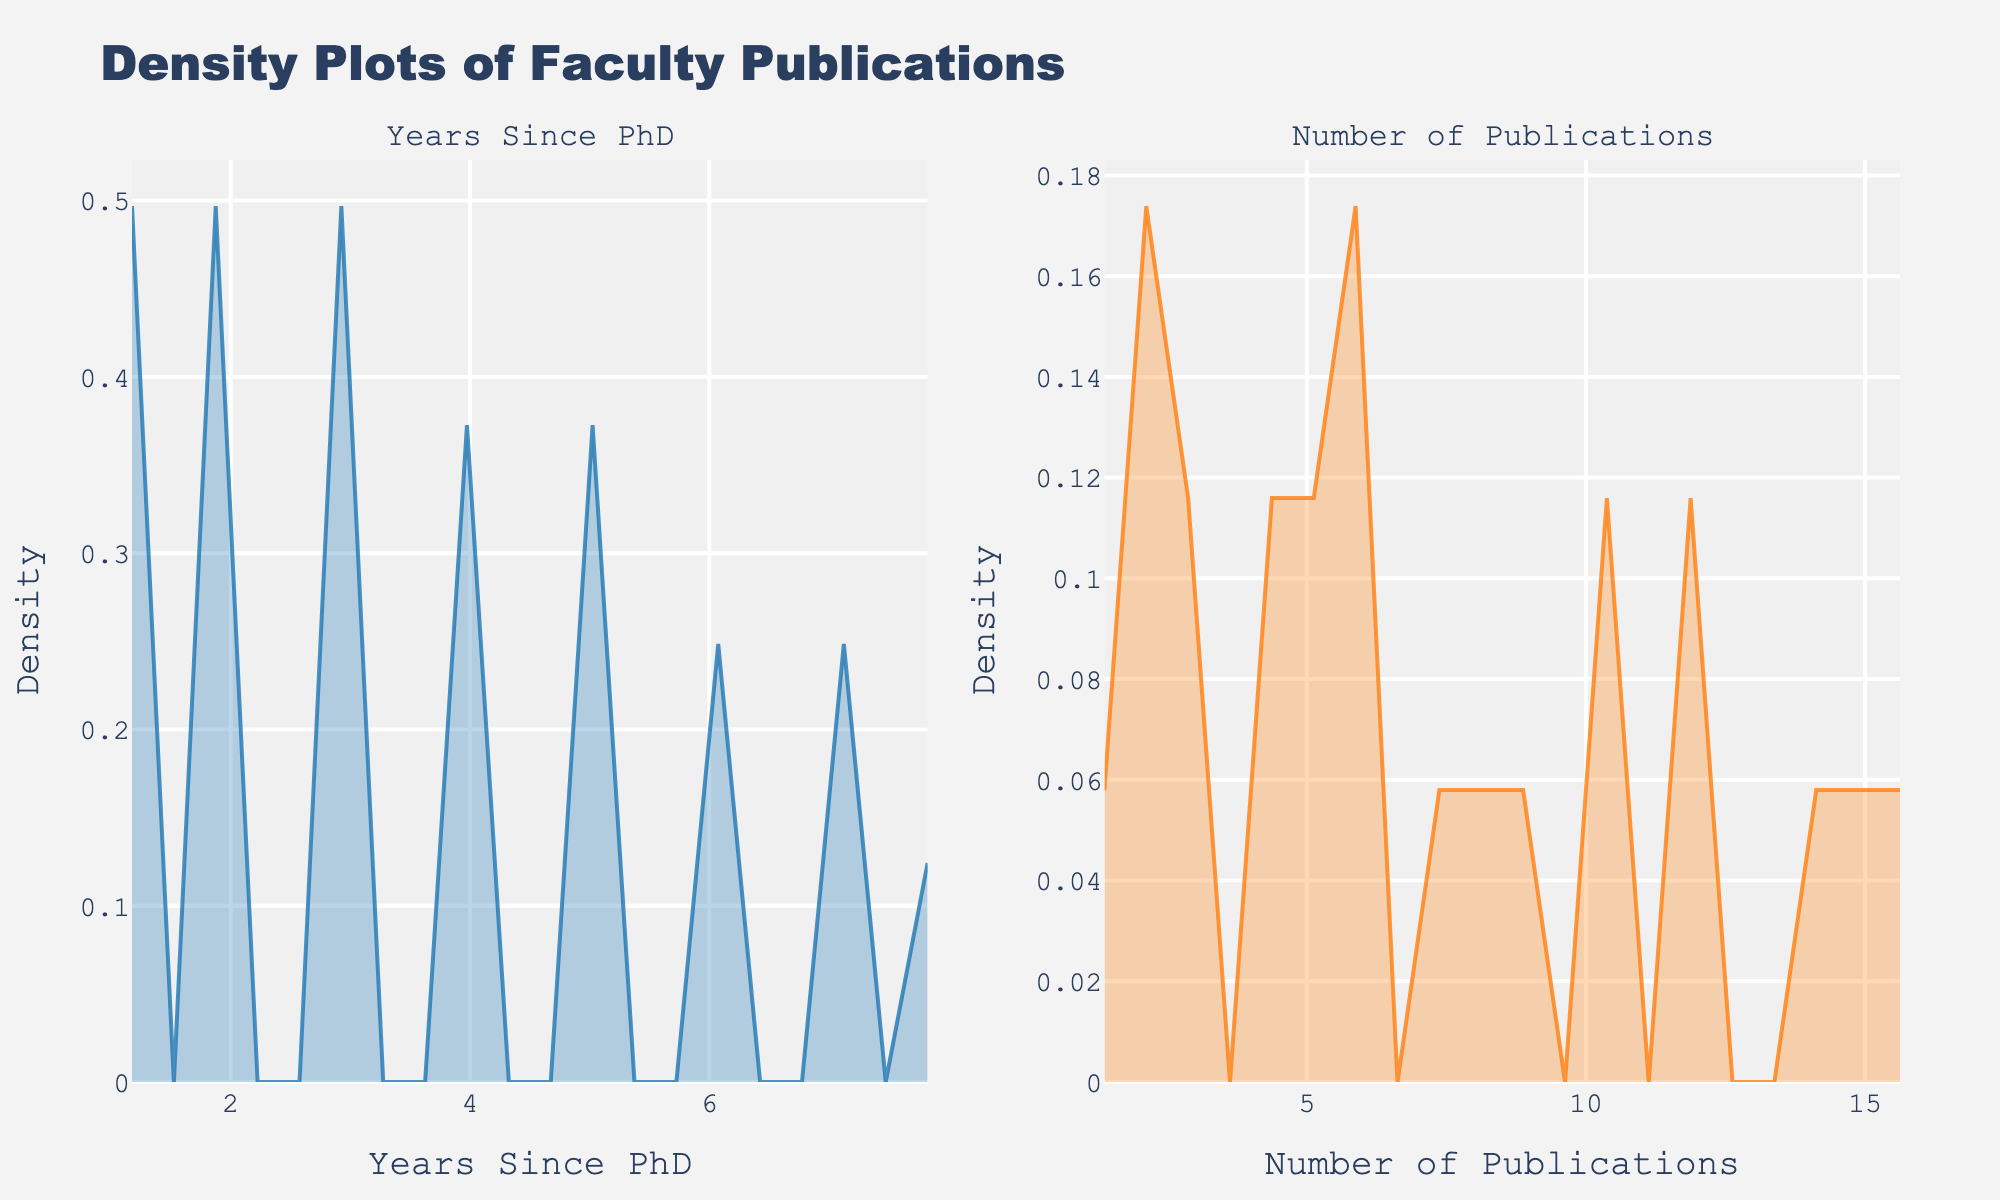How many subplots are in the figure? The figure contains two distinct plots, one for "Years Since PhD" and another for "Number of Publications." Each is a separate density plot within the subplot figure.
Answer: 2 What is the fill color for the "Years Since PhD" density plot? The fill color of the "Years Since PhD" density plot is a transparent shade of blue, giving it a visual representation against the background.
Answer: Transparent blue Which subplot has a higher peak density value? By observing the heights of the peaks in both density plots, you can conclude which one reaches a higher density value. Comparison shows that the "Number of Publications" plot has a higher peak density value than the "Years Since PhD" plot.
Answer: Number of Publications What's the x-axis title for the plot on the left? The xlabel for the left subplot reveals the x-axis title. The subplot represents "Years Since PhD," which is displayed on the x-axis title itself.
Answer: Years Since PhD Approximately at what value of "Number of Publications" does the density plot peak? To find the peak value, locate the highest point on the density curve of the "Number of Publications" subplot. The peak is near the value of 10 publications.
Answer: 10 publications Compare the spread of the two density plots? Evaluate the spread by examining the range and dispersion of the curves on both subplots. The "Number of Publications" density plot has wider dispersion compared to the "Years Since PhD" plot, indicating greater variability in publications.
Answer: Greater dispersion in Number of Publications Where is the peak density point for "Years Since PhD"? Identify the highest density value on the "Years Since PhD" plot by matching the peak point on the y-axis. This peak occurs around 3 years since PhD completion.
Answer: 3 years How do the number of bins in both plots compare? Both subplots use the same number of bins, which is 20, as indicated by the code generating the plots and observed number of peaks/troughs on the density plots.
Answer: Same number of bins Which axis represents density in both subplots? Both density plots have the density represented on the y-axis. This is common with density plots to show the density of data values across the observed x-axis range.
Answer: y-axis How would you describe the overall trend for number of publications over "Years Since PhD"? The overall trend reveals that the density peaks for faculty with around 3 years since PhD and for publications around 10-15, suggesting a trend where publication count increases with more experience.
Answer: Increasing trend 